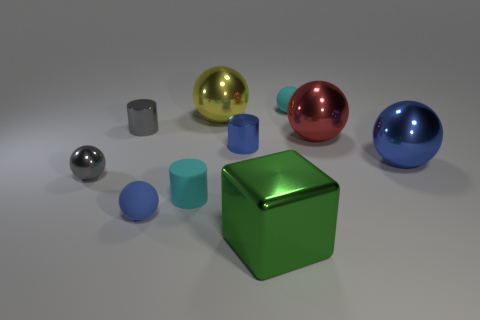Subtract 3 balls. How many balls are left? 3 Subtract all blue spheres. How many spheres are left? 4 Subtract all small blue balls. How many balls are left? 5 Subtract all yellow balls. Subtract all brown cylinders. How many balls are left? 5 Subtract all spheres. How many objects are left? 4 Subtract 0 yellow cylinders. How many objects are left? 10 Subtract all big green cylinders. Subtract all large green metal things. How many objects are left? 9 Add 9 big red spheres. How many big red spheres are left? 10 Add 10 tiny gray cubes. How many tiny gray cubes exist? 10 